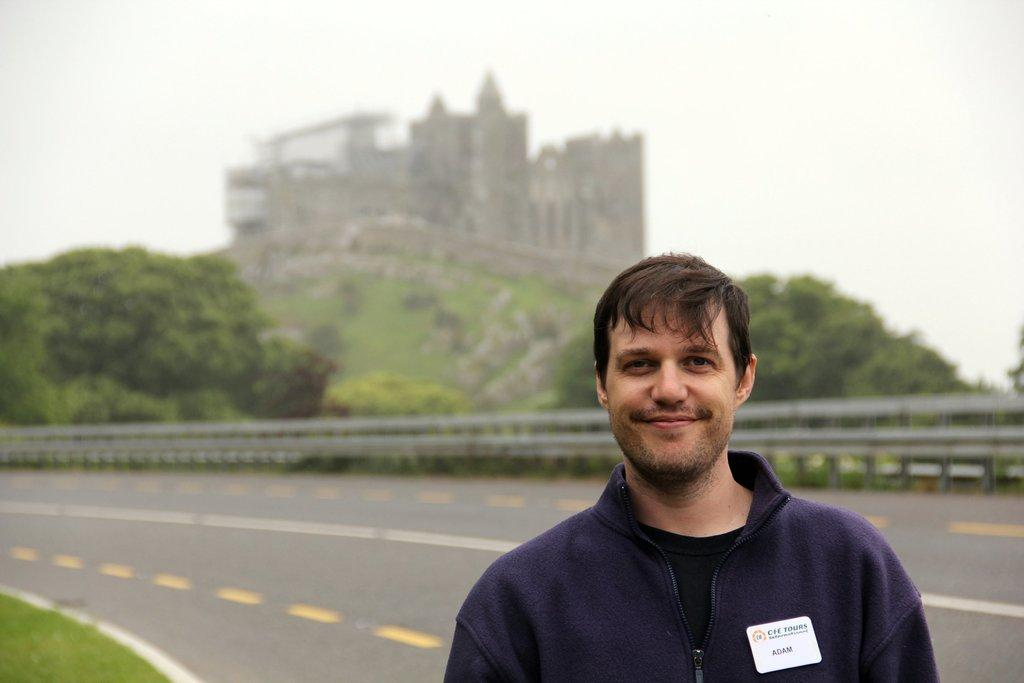What is present in the image? There is a person in the image. What is the person doing? The person is smiling. What can be seen in the background of the image? There is a road, railing, trees, a building, grass, and the sky visible in the background of the image. What is the relation between the person and the plant in the image? There is no plant present in the image; only a person, a road, railing, trees, a building, grass, and the sky are visible. 